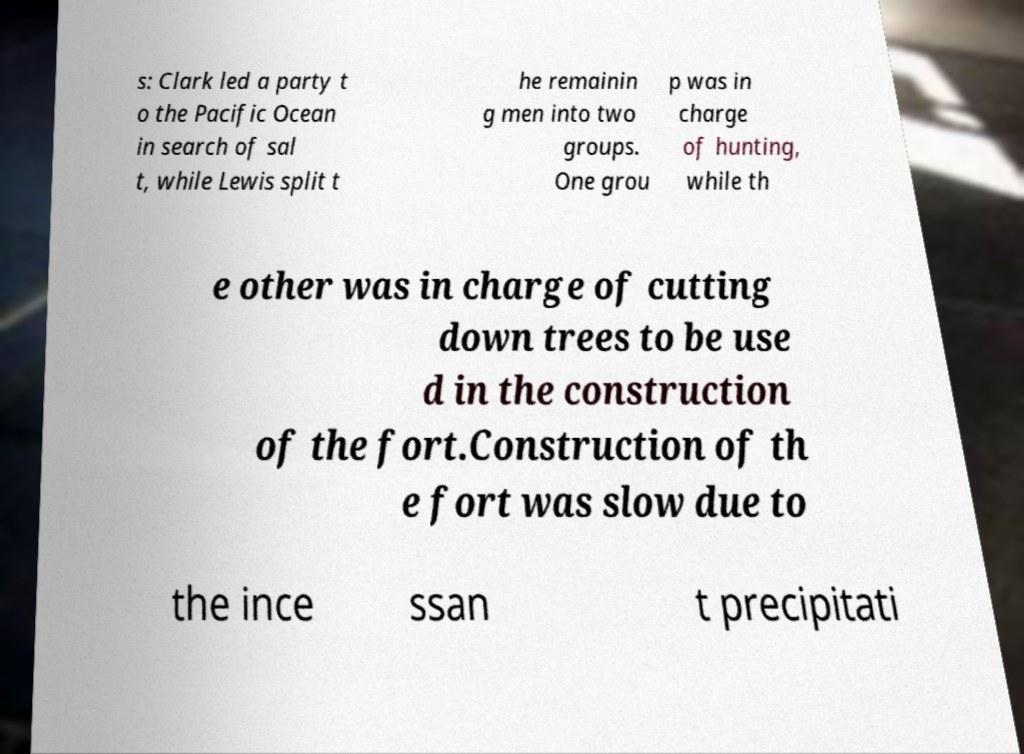Please identify and transcribe the text found in this image. s: Clark led a party t o the Pacific Ocean in search of sal t, while Lewis split t he remainin g men into two groups. One grou p was in charge of hunting, while th e other was in charge of cutting down trees to be use d in the construction of the fort.Construction of th e fort was slow due to the ince ssan t precipitati 